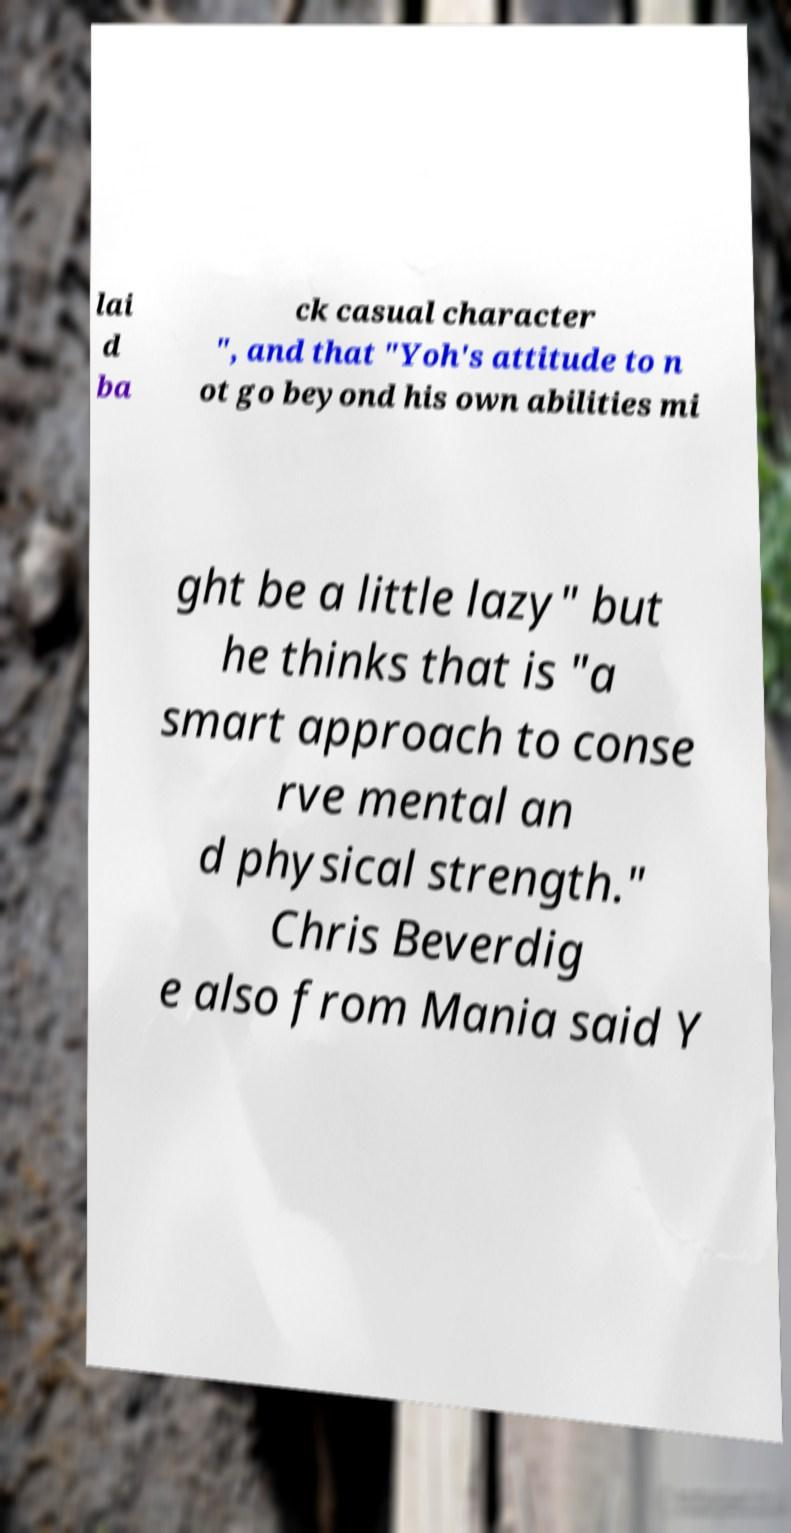Could you assist in decoding the text presented in this image and type it out clearly? lai d ba ck casual character ", and that "Yoh's attitude to n ot go beyond his own abilities mi ght be a little lazy" but he thinks that is "a smart approach to conse rve mental an d physical strength." Chris Beverdig e also from Mania said Y 